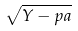Convert formula to latex. <formula><loc_0><loc_0><loc_500><loc_500>\sqrt { Y - p a }</formula> 